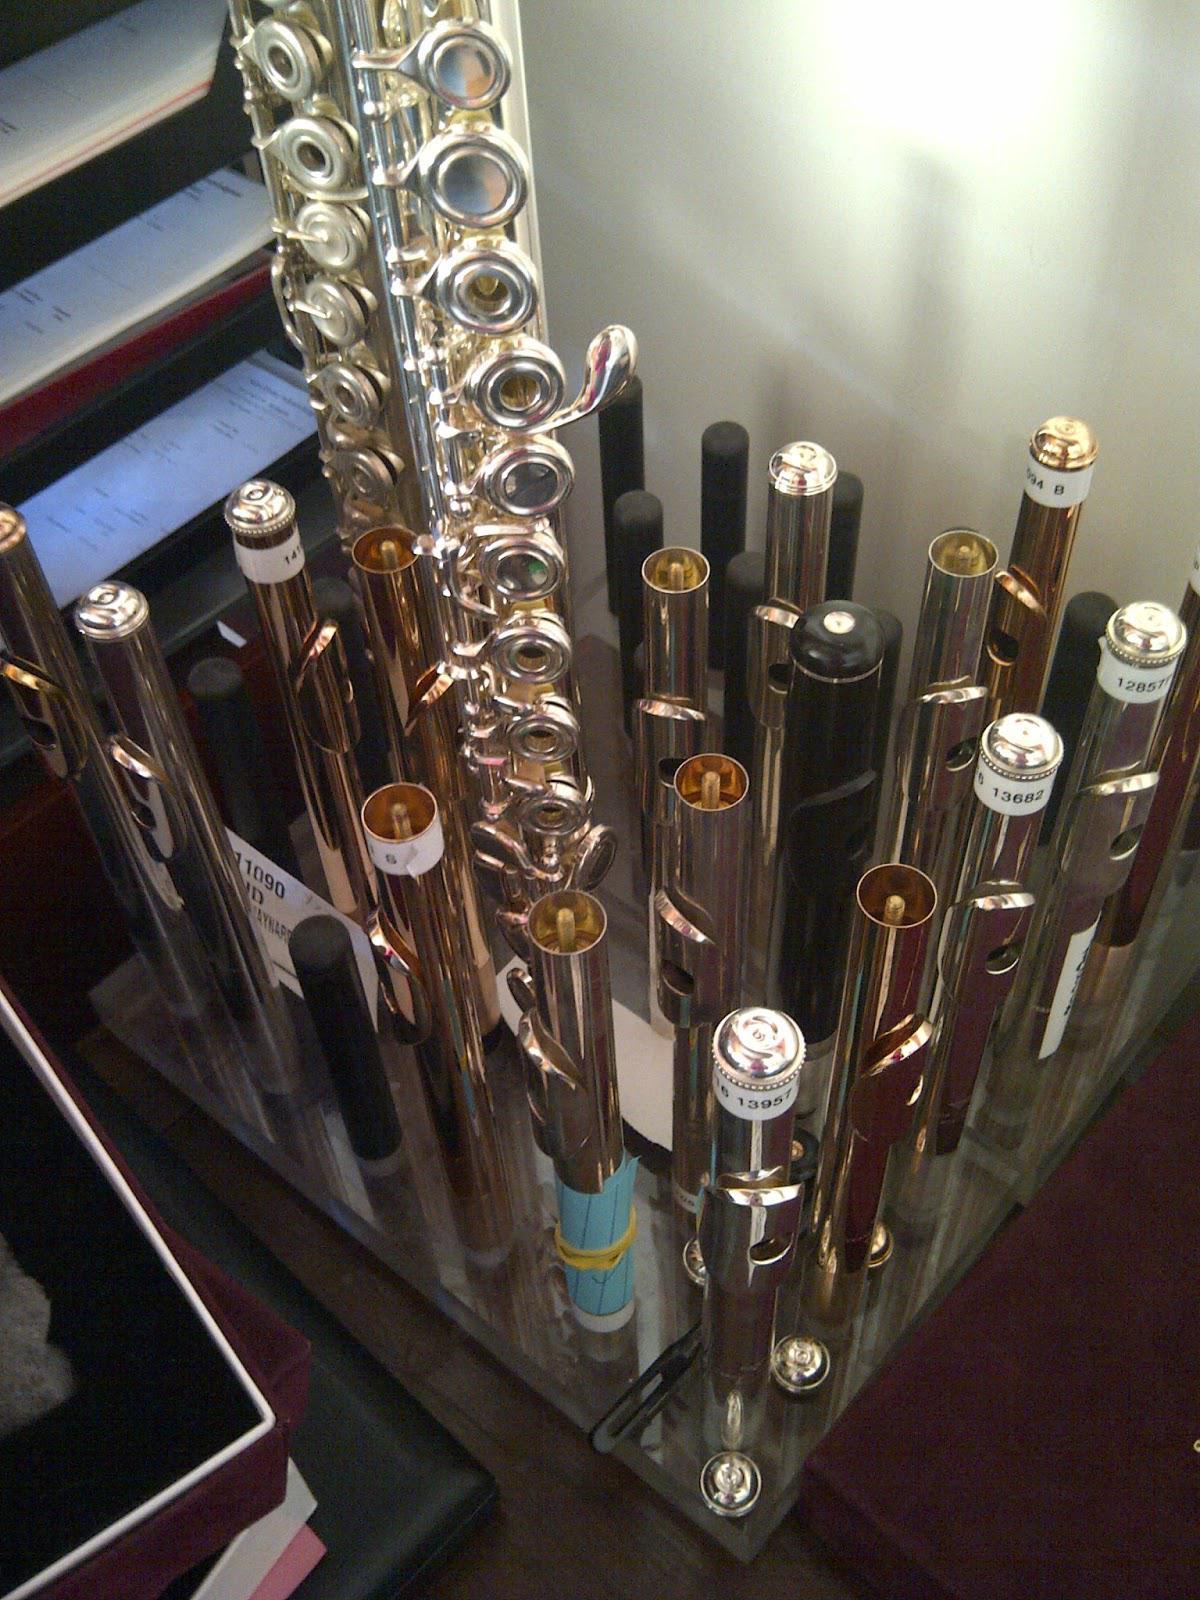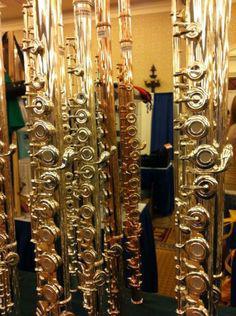The first image is the image on the left, the second image is the image on the right. For the images shown, is this caption "There are exactly two flutes in the right image." true? Answer yes or no. No. The first image is the image on the left, the second image is the image on the right. Considering the images on both sides, is "There is only one instrument in the left image." valid? Answer yes or no. No. 